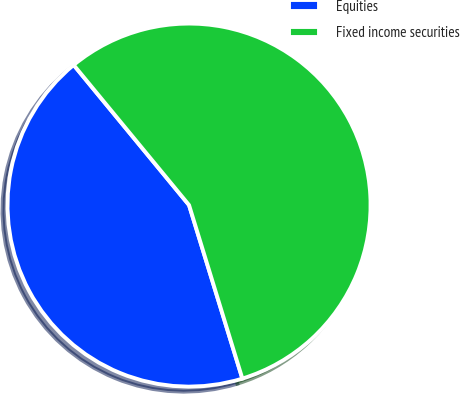Convert chart to OTSL. <chart><loc_0><loc_0><loc_500><loc_500><pie_chart><fcel>Equities<fcel>Fixed income securities<nl><fcel>43.78%<fcel>56.22%<nl></chart> 